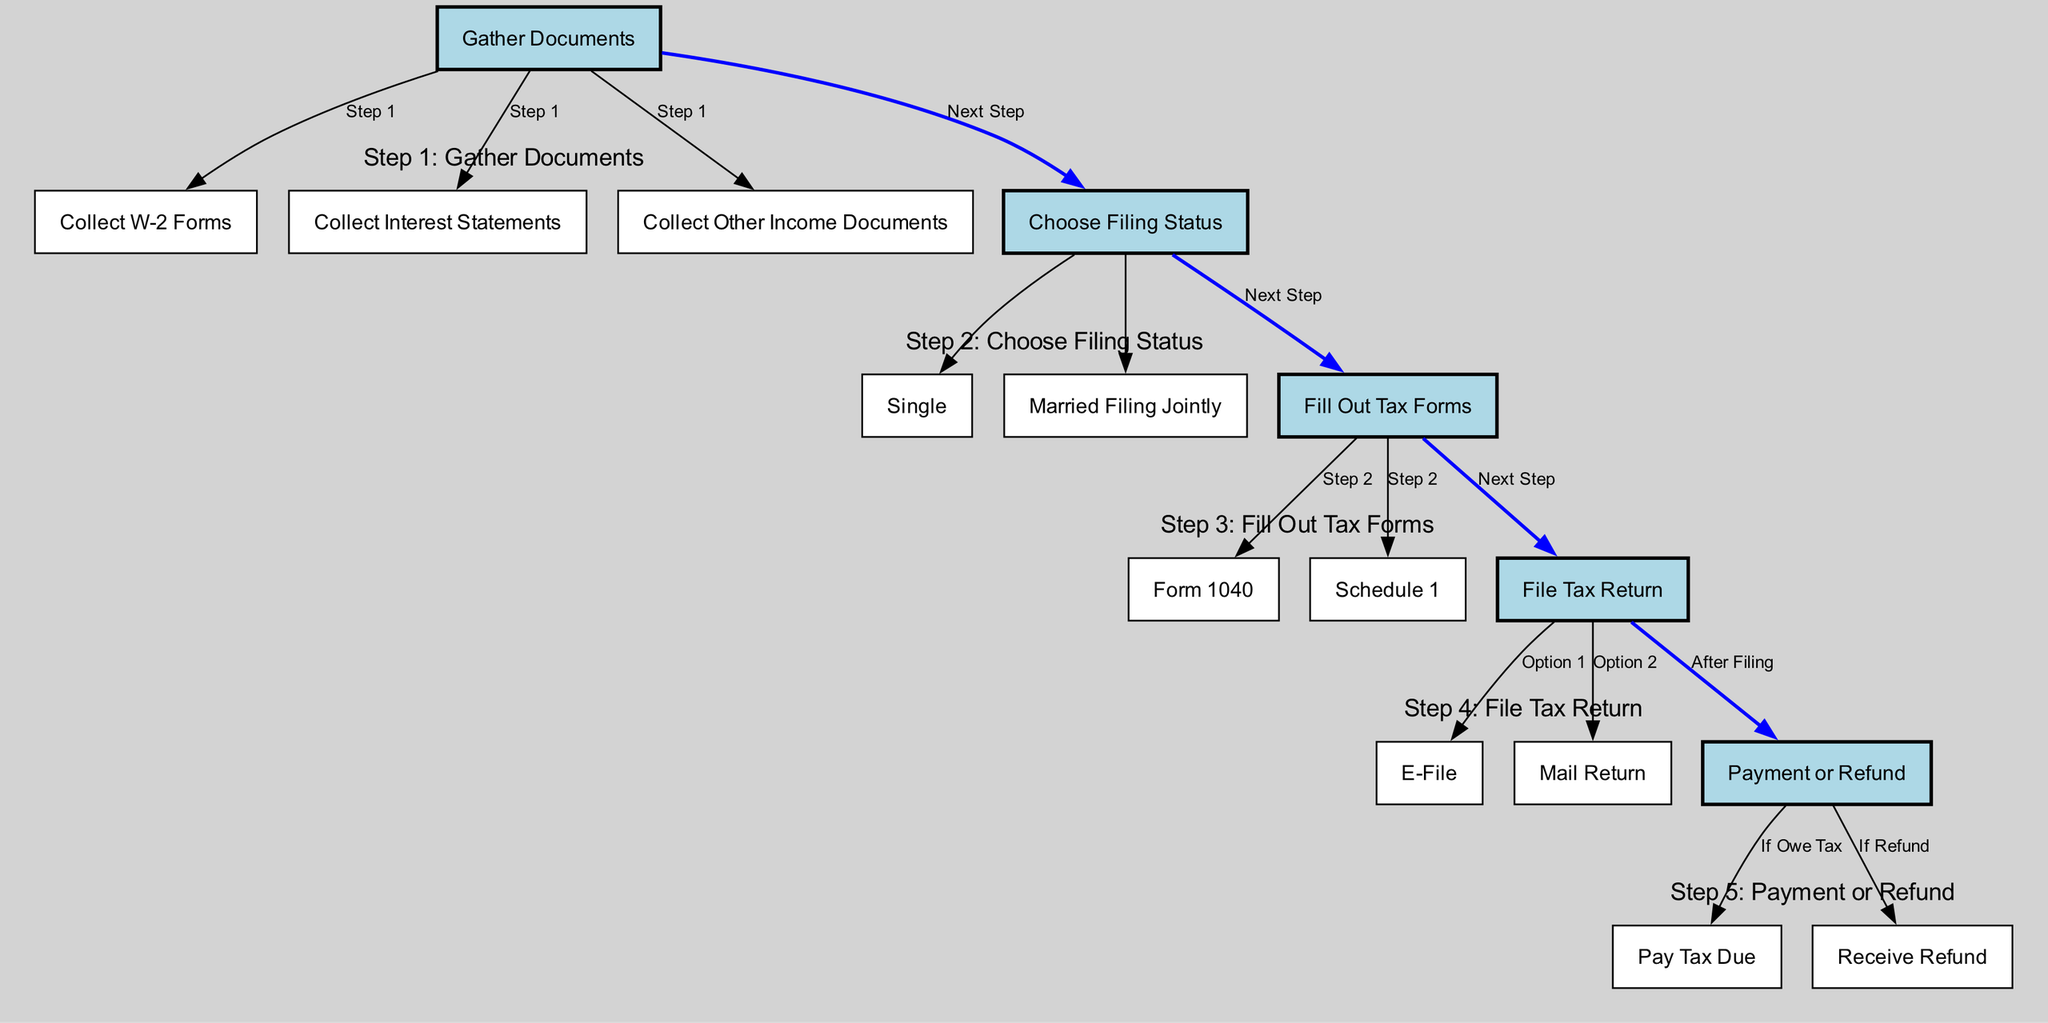What is the first step in the tax filing process? The first step is to gather all necessary documents for filing. According to the diagram, this is the initial action to take before proceeding with any other part of the tax filing process.
Answer: Gather Documents How many types of income documents do you need to collect? The diagram indicates three types of income documents that must be collected: W-2 forms, interest statements, and other income documents. Therefore, the total count is three.
Answer: Three What are the two options for filing the tax return? The diagram indicates the two options for filing the tax return: E-File and Mail Return. Both options are displayed as alternatives in the diagram with clear paths leading to them.
Answer: E-File and Mail Return What follows after filling out tax forms? After filling out the tax forms, the next step is to file the tax return. This flow can be traced in the diagram from the fill tax forms node to the file tax return node, indicating this sequential process.
Answer: File Tax Return What filing status choices are available? The diagram presents two choices for filing status: Single and Married Filing Jointly. These options are branches stemming from the choose filing status node in the flow.
Answer: Single and Married Filing Jointly What happens if you owe tax after filing? If you owe tax after filing, the next step is to pay the tax due. This action follows a clear path from the payment or refund node leading towards paying tax in the diagram.
Answer: Pay Tax Due How many main steps are outlined in the process? The diagram outlines five main steps, each defined by a subgraph. Counting them gives us the total number of main steps highlighted for filing tax returns.
Answer: Five What type of form is used to fill out tax information? The form used to fill out tax information is Form 1040, as indicated in the diagram. This form is a key element associated with the step of filling tax forms.
Answer: Form 1040 